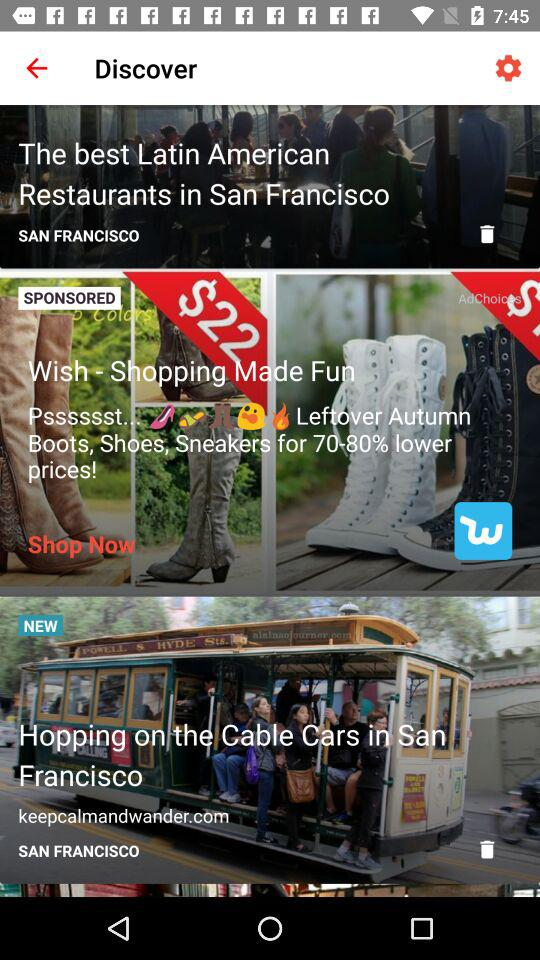What's new in Discover? The new in discover is "Hopping on the Cable Cars in San Francisco". 